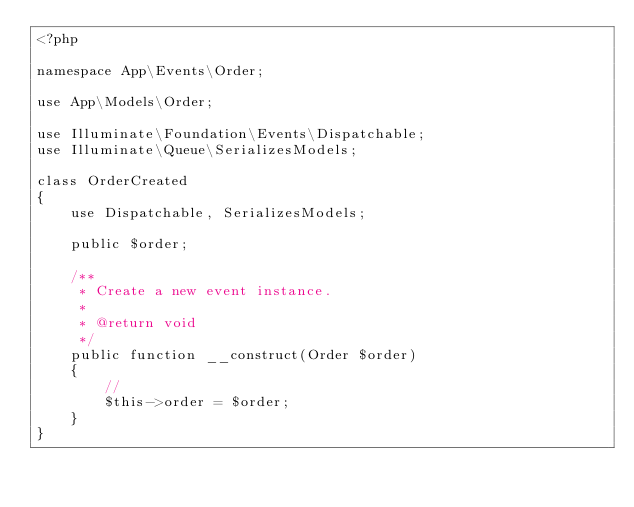<code> <loc_0><loc_0><loc_500><loc_500><_PHP_><?php

namespace App\Events\Order;

use App\Models\Order;

use Illuminate\Foundation\Events\Dispatchable;
use Illuminate\Queue\SerializesModels;

class OrderCreated
{
    use Dispatchable, SerializesModels;

    public $order;

    /**
     * Create a new event instance.
     *
     * @return void
     */
    public function __construct(Order $order)
    {
        //
        $this->order = $order;
    }
}
</code> 